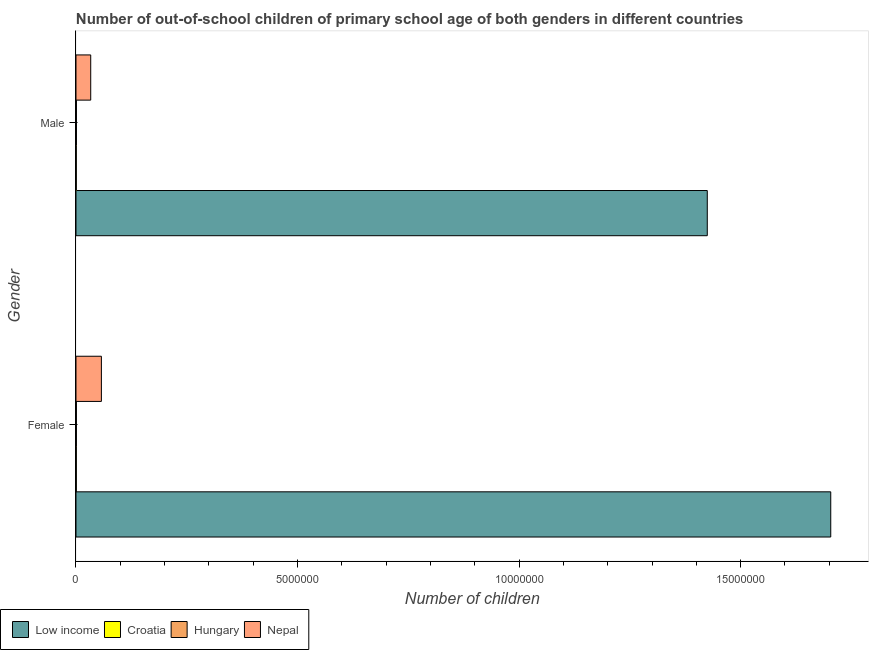Are the number of bars per tick equal to the number of legend labels?
Make the answer very short. Yes. How many bars are there on the 1st tick from the bottom?
Offer a terse response. 4. What is the number of female out-of-school students in Croatia?
Offer a terse response. 7567. Across all countries, what is the maximum number of female out-of-school students?
Provide a succinct answer. 1.70e+07. Across all countries, what is the minimum number of male out-of-school students?
Offer a very short reply. 6765. In which country was the number of female out-of-school students maximum?
Offer a very short reply. Low income. In which country was the number of female out-of-school students minimum?
Make the answer very short. Croatia. What is the total number of female out-of-school students in the graph?
Your response must be concise. 1.76e+07. What is the difference between the number of male out-of-school students in Low income and that in Hungary?
Your answer should be compact. 1.42e+07. What is the difference between the number of female out-of-school students in Hungary and the number of male out-of-school students in Low income?
Give a very brief answer. -1.42e+07. What is the average number of male out-of-school students per country?
Offer a terse response. 3.65e+06. What is the difference between the number of female out-of-school students and number of male out-of-school students in Croatia?
Ensure brevity in your answer.  802. In how many countries, is the number of female out-of-school students greater than 6000000 ?
Provide a short and direct response. 1. What is the ratio of the number of male out-of-school students in Low income to that in Croatia?
Provide a short and direct response. 2105.93. Is the number of female out-of-school students in Nepal less than that in Hungary?
Provide a succinct answer. No. In how many countries, is the number of male out-of-school students greater than the average number of male out-of-school students taken over all countries?
Your response must be concise. 1. What does the 2nd bar from the top in Female represents?
Make the answer very short. Hungary. What does the 3rd bar from the bottom in Female represents?
Make the answer very short. Hungary. How many bars are there?
Make the answer very short. 8. Are all the bars in the graph horizontal?
Provide a short and direct response. Yes. Are the values on the major ticks of X-axis written in scientific E-notation?
Ensure brevity in your answer.  No. Does the graph contain any zero values?
Your answer should be compact. No. Where does the legend appear in the graph?
Offer a terse response. Bottom left. What is the title of the graph?
Your answer should be compact. Number of out-of-school children of primary school age of both genders in different countries. What is the label or title of the X-axis?
Your answer should be very brief. Number of children. What is the label or title of the Y-axis?
Provide a succinct answer. Gender. What is the Number of children of Low income in Female?
Provide a succinct answer. 1.70e+07. What is the Number of children of Croatia in Female?
Keep it short and to the point. 7567. What is the Number of children in Hungary in Female?
Offer a very short reply. 9317. What is the Number of children in Nepal in Female?
Offer a terse response. 5.73e+05. What is the Number of children in Low income in Male?
Provide a short and direct response. 1.42e+07. What is the Number of children of Croatia in Male?
Offer a terse response. 6765. What is the Number of children of Hungary in Male?
Offer a terse response. 1.00e+04. What is the Number of children of Nepal in Male?
Provide a short and direct response. 3.33e+05. Across all Gender, what is the maximum Number of children in Low income?
Offer a very short reply. 1.70e+07. Across all Gender, what is the maximum Number of children of Croatia?
Your response must be concise. 7567. Across all Gender, what is the maximum Number of children of Hungary?
Your answer should be compact. 1.00e+04. Across all Gender, what is the maximum Number of children in Nepal?
Make the answer very short. 5.73e+05. Across all Gender, what is the minimum Number of children of Low income?
Give a very brief answer. 1.42e+07. Across all Gender, what is the minimum Number of children in Croatia?
Provide a short and direct response. 6765. Across all Gender, what is the minimum Number of children in Hungary?
Offer a terse response. 9317. Across all Gender, what is the minimum Number of children in Nepal?
Your answer should be compact. 3.33e+05. What is the total Number of children of Low income in the graph?
Keep it short and to the point. 3.13e+07. What is the total Number of children in Croatia in the graph?
Give a very brief answer. 1.43e+04. What is the total Number of children of Hungary in the graph?
Keep it short and to the point. 1.93e+04. What is the total Number of children of Nepal in the graph?
Give a very brief answer. 9.06e+05. What is the difference between the Number of children in Low income in Female and that in Male?
Provide a succinct answer. 2.79e+06. What is the difference between the Number of children of Croatia in Female and that in Male?
Provide a succinct answer. 802. What is the difference between the Number of children of Hungary in Female and that in Male?
Ensure brevity in your answer.  -714. What is the difference between the Number of children in Nepal in Female and that in Male?
Make the answer very short. 2.41e+05. What is the difference between the Number of children of Low income in Female and the Number of children of Croatia in Male?
Offer a terse response. 1.70e+07. What is the difference between the Number of children in Low income in Female and the Number of children in Hungary in Male?
Provide a short and direct response. 1.70e+07. What is the difference between the Number of children of Low income in Female and the Number of children of Nepal in Male?
Keep it short and to the point. 1.67e+07. What is the difference between the Number of children of Croatia in Female and the Number of children of Hungary in Male?
Provide a succinct answer. -2464. What is the difference between the Number of children of Croatia in Female and the Number of children of Nepal in Male?
Ensure brevity in your answer.  -3.25e+05. What is the difference between the Number of children of Hungary in Female and the Number of children of Nepal in Male?
Ensure brevity in your answer.  -3.23e+05. What is the average Number of children of Low income per Gender?
Your answer should be compact. 1.56e+07. What is the average Number of children in Croatia per Gender?
Offer a terse response. 7166. What is the average Number of children of Hungary per Gender?
Make the answer very short. 9674. What is the average Number of children of Nepal per Gender?
Make the answer very short. 4.53e+05. What is the difference between the Number of children of Low income and Number of children of Croatia in Female?
Offer a very short reply. 1.70e+07. What is the difference between the Number of children in Low income and Number of children in Hungary in Female?
Keep it short and to the point. 1.70e+07. What is the difference between the Number of children of Low income and Number of children of Nepal in Female?
Keep it short and to the point. 1.65e+07. What is the difference between the Number of children in Croatia and Number of children in Hungary in Female?
Your response must be concise. -1750. What is the difference between the Number of children of Croatia and Number of children of Nepal in Female?
Offer a very short reply. -5.66e+05. What is the difference between the Number of children in Hungary and Number of children in Nepal in Female?
Give a very brief answer. -5.64e+05. What is the difference between the Number of children in Low income and Number of children in Croatia in Male?
Keep it short and to the point. 1.42e+07. What is the difference between the Number of children in Low income and Number of children in Hungary in Male?
Your answer should be very brief. 1.42e+07. What is the difference between the Number of children in Low income and Number of children in Nepal in Male?
Keep it short and to the point. 1.39e+07. What is the difference between the Number of children in Croatia and Number of children in Hungary in Male?
Keep it short and to the point. -3266. What is the difference between the Number of children in Croatia and Number of children in Nepal in Male?
Your answer should be compact. -3.26e+05. What is the difference between the Number of children of Hungary and Number of children of Nepal in Male?
Offer a terse response. -3.23e+05. What is the ratio of the Number of children in Low income in Female to that in Male?
Your answer should be compact. 1.2. What is the ratio of the Number of children of Croatia in Female to that in Male?
Your answer should be very brief. 1.12. What is the ratio of the Number of children in Hungary in Female to that in Male?
Offer a very short reply. 0.93. What is the ratio of the Number of children in Nepal in Female to that in Male?
Your answer should be compact. 1.72. What is the difference between the highest and the second highest Number of children of Low income?
Provide a succinct answer. 2.79e+06. What is the difference between the highest and the second highest Number of children in Croatia?
Your response must be concise. 802. What is the difference between the highest and the second highest Number of children of Hungary?
Give a very brief answer. 714. What is the difference between the highest and the second highest Number of children in Nepal?
Ensure brevity in your answer.  2.41e+05. What is the difference between the highest and the lowest Number of children in Low income?
Offer a terse response. 2.79e+06. What is the difference between the highest and the lowest Number of children in Croatia?
Offer a terse response. 802. What is the difference between the highest and the lowest Number of children of Hungary?
Make the answer very short. 714. What is the difference between the highest and the lowest Number of children of Nepal?
Your response must be concise. 2.41e+05. 